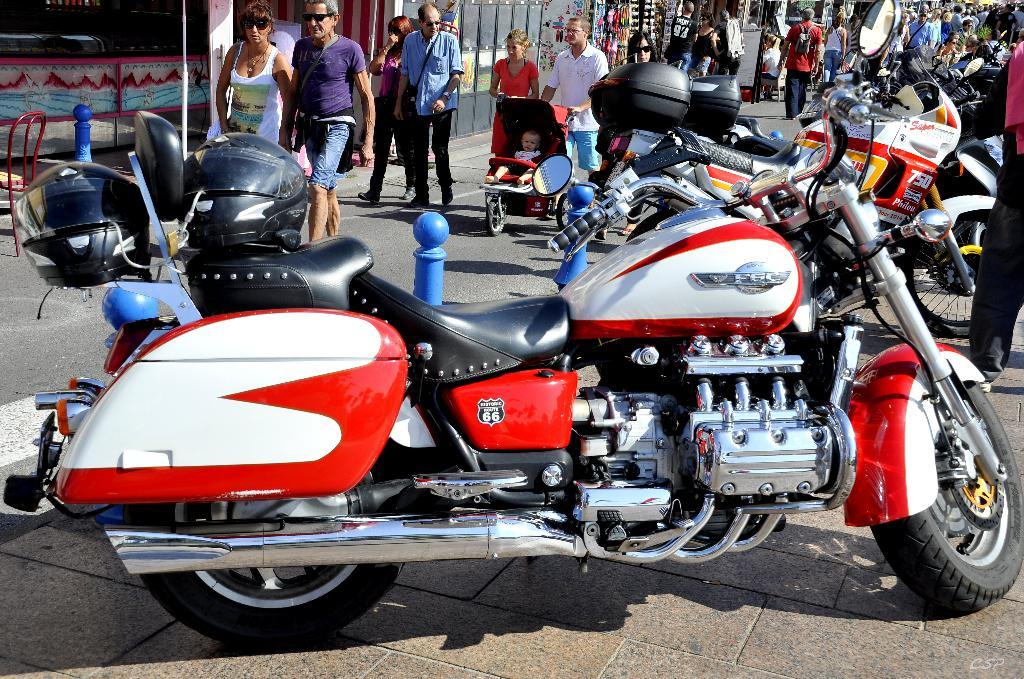Provide a one-sentence caption for the provided image. The F6C can be driven along the Route 66. 